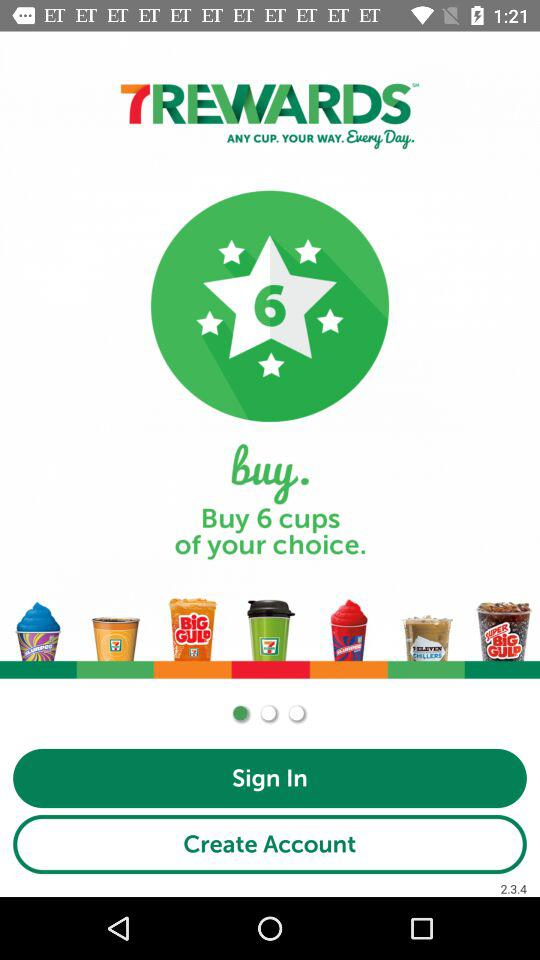How many ice cream cups are pictured in the row?
Answer the question using a single word or phrase. 7 